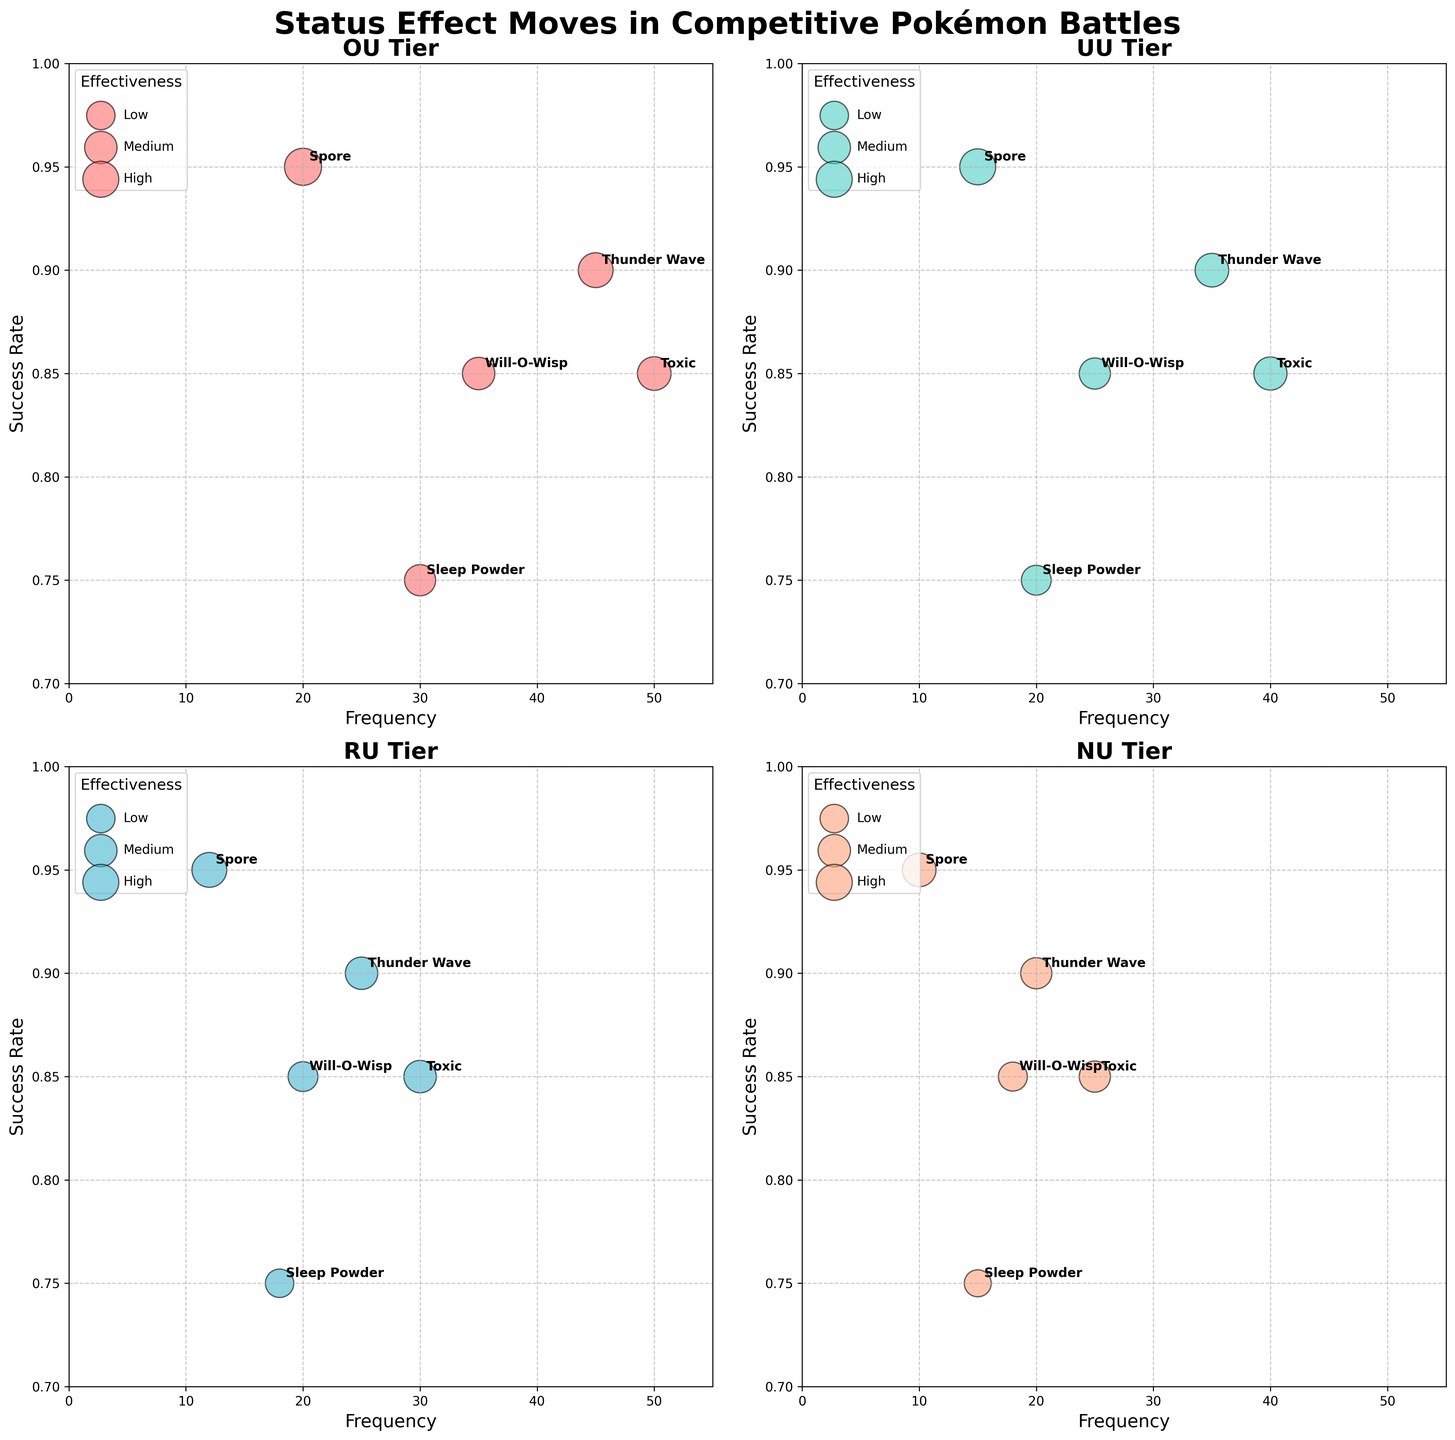What is the title of the main plot? The main title of the plot is located at the top center of the figure and reads "Status Effect Moves in Competitive Pokémon Battles".
Answer: Status Effect Moves in Competitive Pokémon Battles In the OU tier, which status effect move has the highest frequency? By looking at the x-axis of the subplot corresponding to the OU tier, the move with the highest frequency is at the farthest right. In this case, it is "Toxic".
Answer: Toxic Between Thunder Wave and Will-O-Wisp in the UU tier, which move has the higher success rate? In the subplot corresponding to the UU tier, compare the y-axis values for Thunder Wave and Will-O-Wisp. Thunder Wave has a success rate of 0.90, while Will-O-Wisp has a success rate of 0.85. Therefore, Thunder Wave has the higher success rate.
Answer: Thunder Wave What’s the aggregate frequency of Sleep Powder across all tiers? Sum the frequencies of Sleep Powder across all tiers: 30 (OU) + 20 (UU) + 18 (RU) + 15 (NU) = 83.
Answer: 83 Which tier has the lowest overall effectiveness for the move Spore? To find the tier with the lowest overall effectiveness for Spore, compare the bubble sizes (and refer to the actual effectiveness data) across all subplots for the Spore move. The NU tier has the smallest bubble, meaning the lowest overall effectiveness of 0.70.
Answer: NU Does Toxic have the same success rate across all tiers? Review the y-axis values for Toxic in each subplot. Toxic has a consistent success rate of 0.85 in all tiers (OU, UU, RU, NU).
Answer: Yes Which move has the highest effectiveness in the RU tier? In the RU tier subplot, look for the largest bubble size since effectiveness is represented by bubble size. The largest bubble corresponds to "Spore".
Answer: Spore How does the frequency of Will-O-Wisp in the RU tier compare to that in the NU tier? Compare the x-axis values for Will-O-Wisp in the RU and NU tier subplots. Will-O-Wisp has a frequency of 20 in the RU tier and 18 in the NU tier. RU's frequency is higher.
Answer: RU has a higher frequency Is there a move in the NU tier with a success rate below 0.75? Review the y-axis values in the NU tier for any move with a success rate below 0.75. Sleep Powder in the NU tier has a success rate of 0.75, quite close but not below.
Answer: No Which tier shows the highest consistency in success rate for moves? Determine the tier with the least variation (tightest clustering along the y-axis) in move success rates. All tiers show high consistency, but UU and RU tier both have moves tightly clustered at success rates mostly around 0.85-0.90.
Answer: UU or RU 